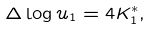<formula> <loc_0><loc_0><loc_500><loc_500>\Delta \log u _ { 1 } = 4 K _ { 1 } ^ { * } ,</formula> 